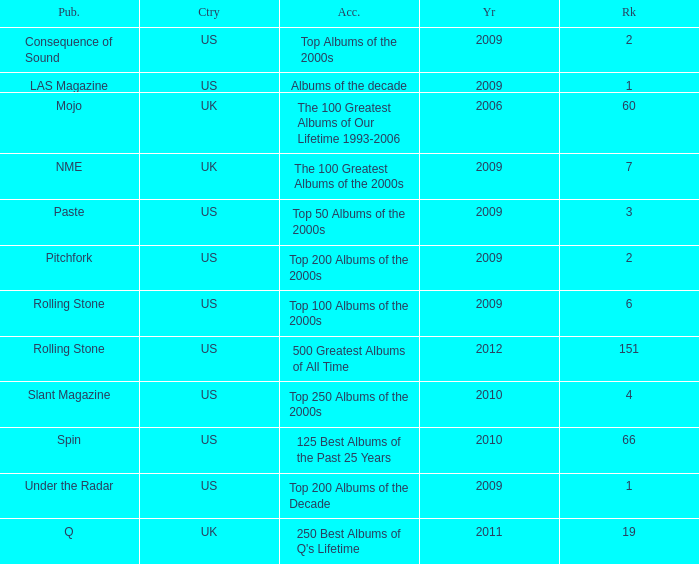What was the lowest rank after 2009 with an accolade of 125 best albums of the past 25 years? 66.0. 